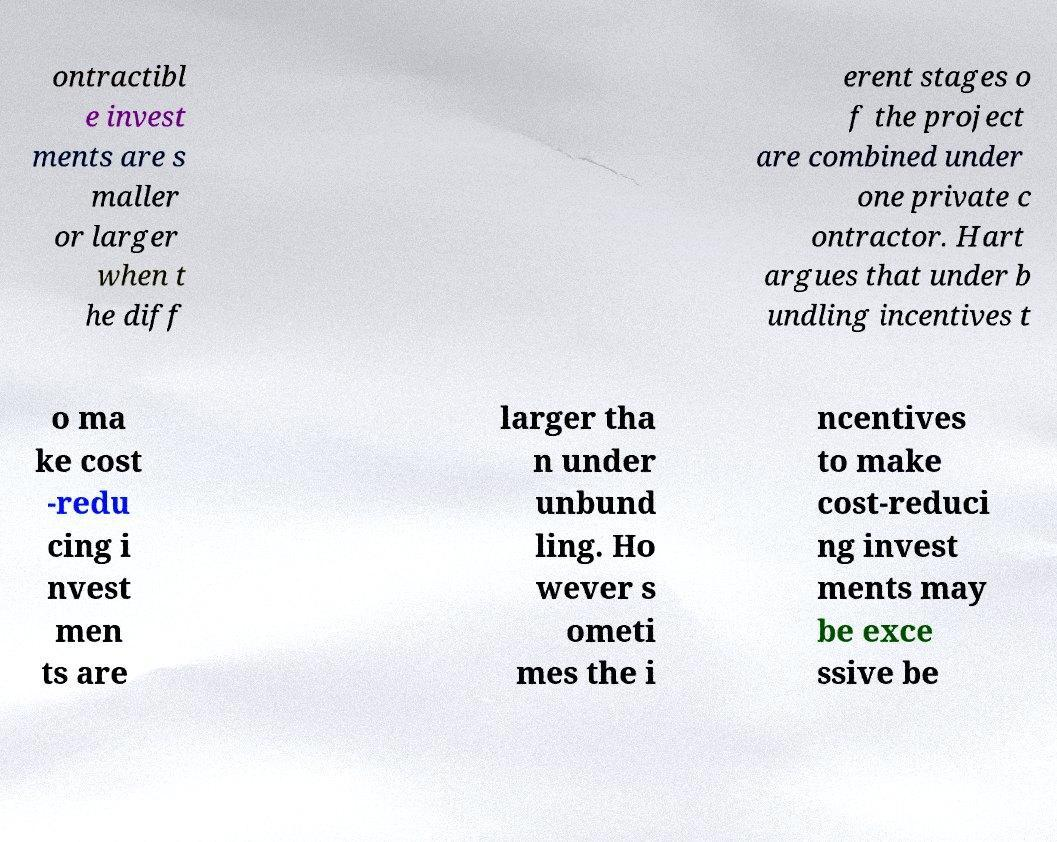I need the written content from this picture converted into text. Can you do that? ontractibl e invest ments are s maller or larger when t he diff erent stages o f the project are combined under one private c ontractor. Hart argues that under b undling incentives t o ma ke cost -redu cing i nvest men ts are larger tha n under unbund ling. Ho wever s ometi mes the i ncentives to make cost-reduci ng invest ments may be exce ssive be 